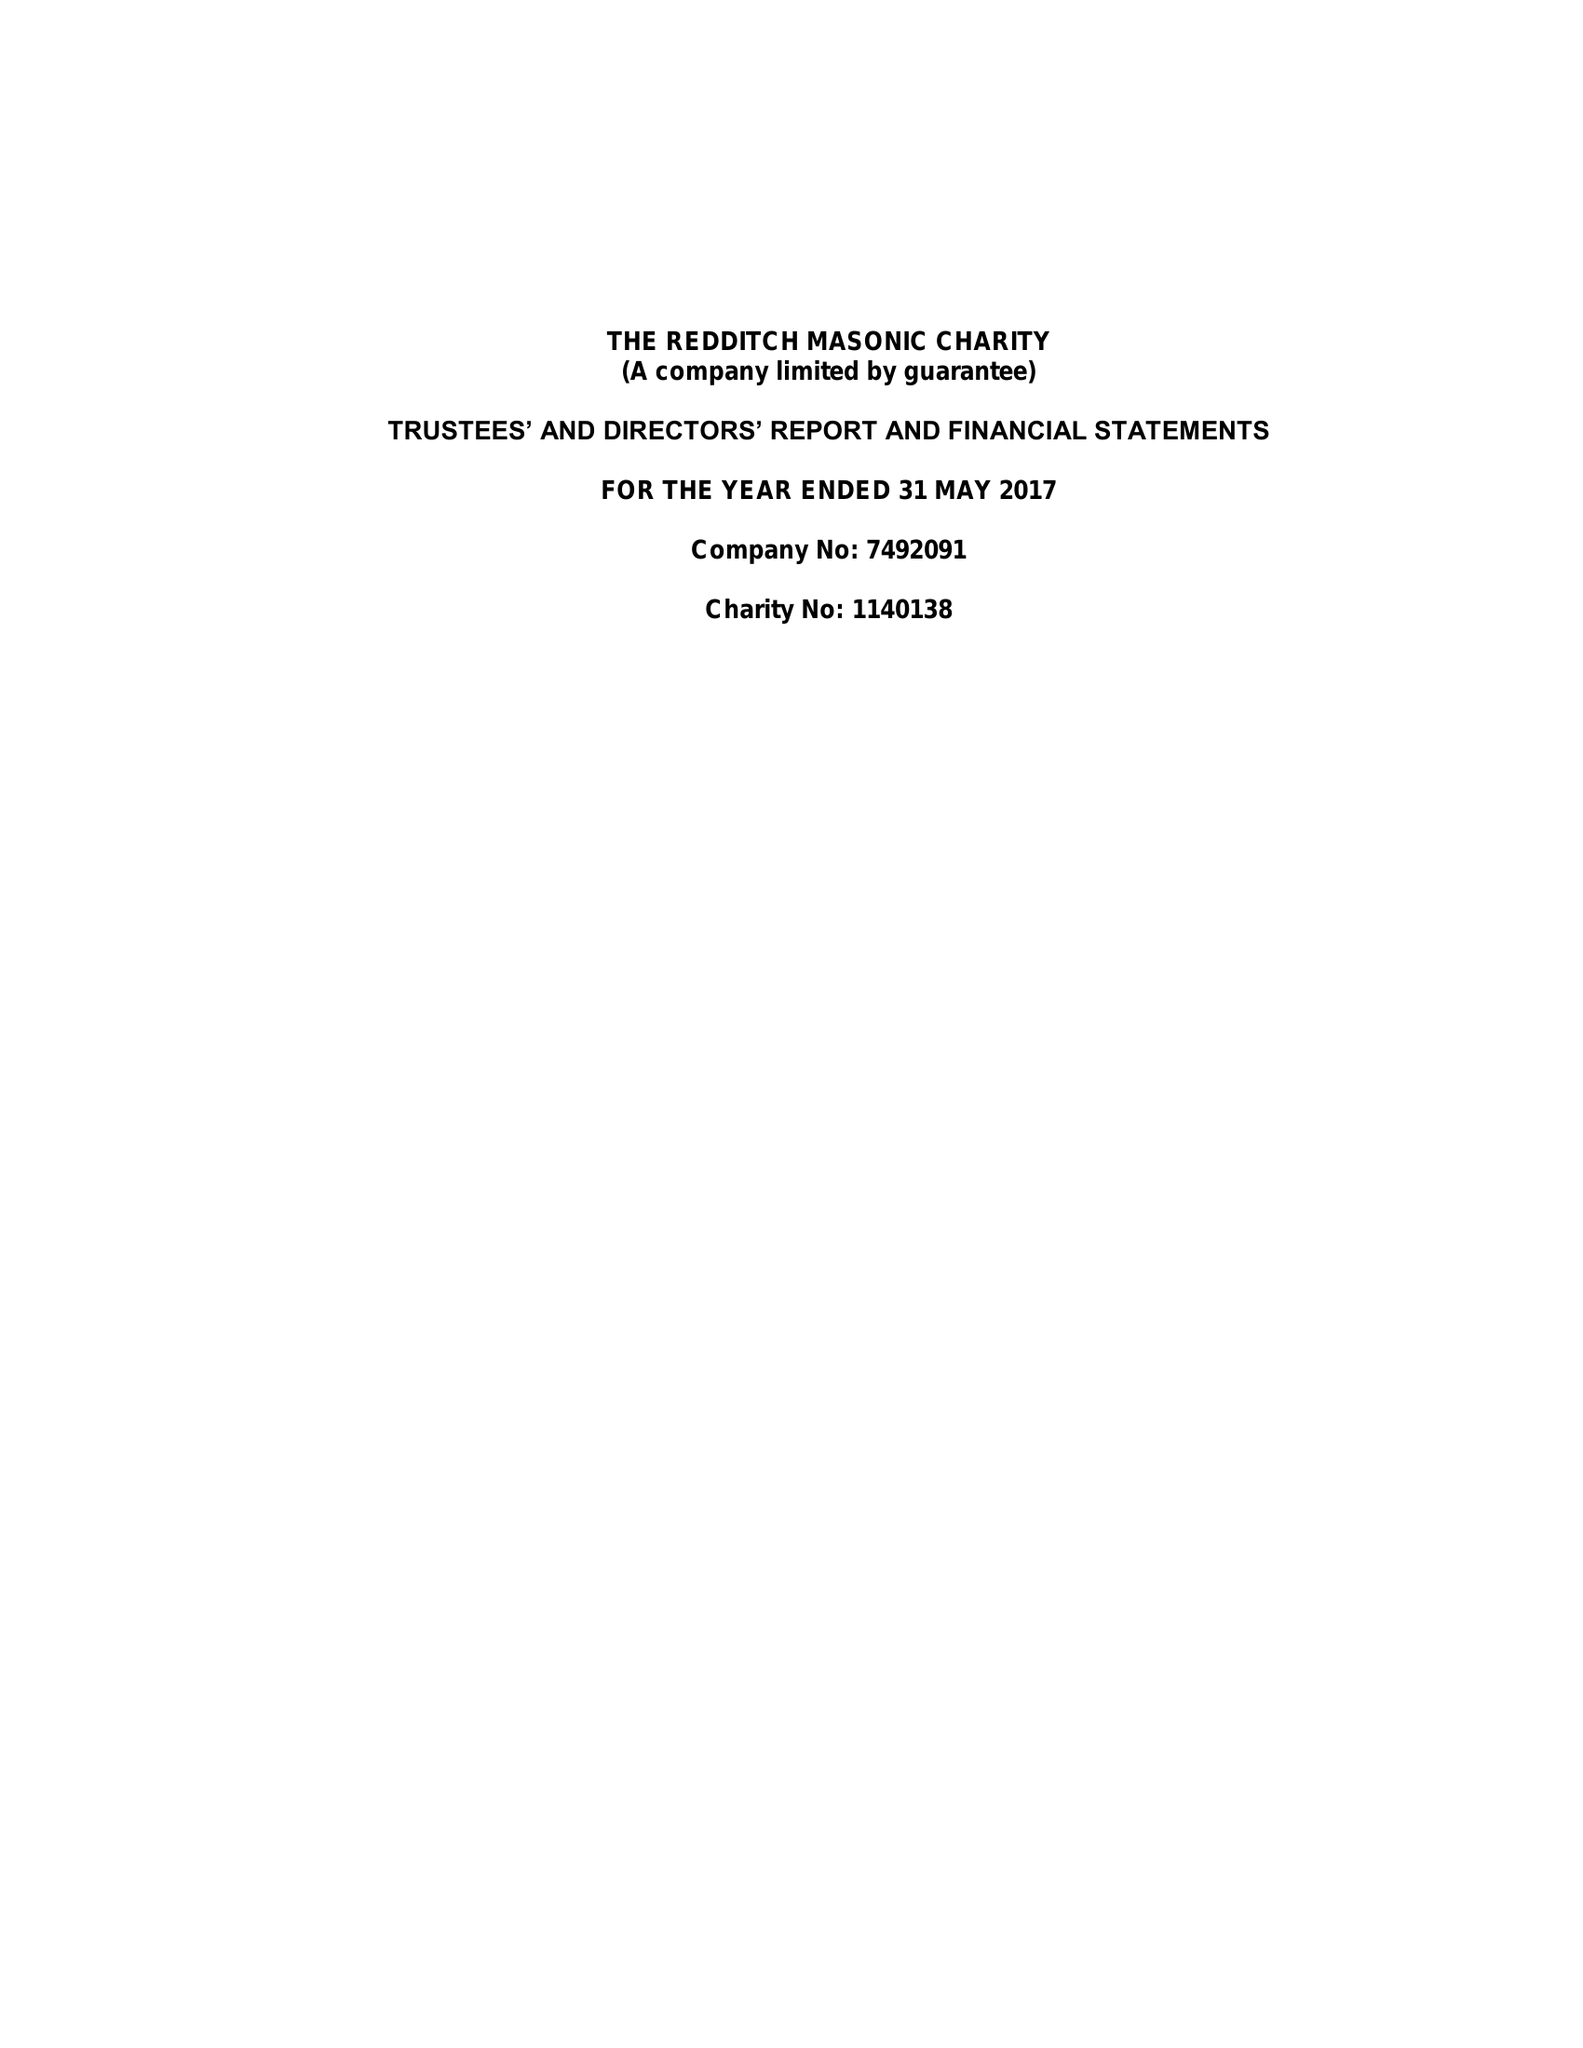What is the value for the address__postcode?
Answer the question using a single word or phrase. B97 5UY 